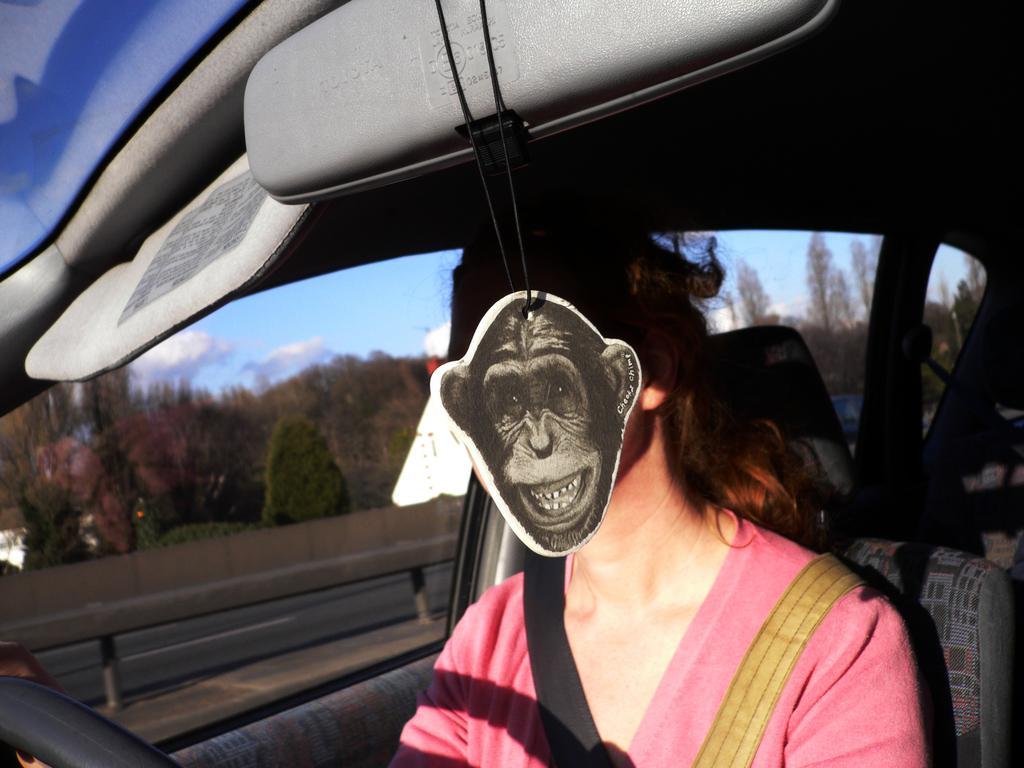Could you give a brief overview of what you see in this image? This image is clicked inside a vehicle. There is a person sitting on the seat. The person is wearing a seatbelt. Beside the person there are windows to the vehicle. Outside the windows there are trees and sky. At the top there is an object. There is a mask of a monkey hanging to the object. 